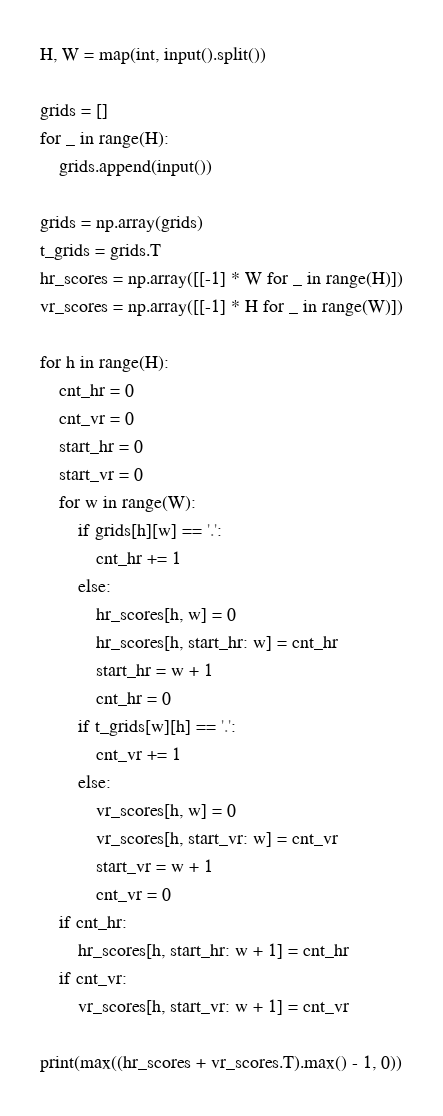<code> <loc_0><loc_0><loc_500><loc_500><_Python_>H, W = map(int, input().split())

grids = []
for _ in range(H):
    grids.append(input())

grids = np.array(grids)
t_grids = grids.T
hr_scores = np.array([[-1] * W for _ in range(H)])
vr_scores = np.array([[-1] * H for _ in range(W)])

for h in range(H):
    cnt_hr = 0
    cnt_vr = 0
    start_hr = 0
    start_vr = 0
    for w in range(W):
        if grids[h][w] == '.':
            cnt_hr += 1
        else:
            hr_scores[h, w] = 0
            hr_scores[h, start_hr: w] = cnt_hr
            start_hr = w + 1
            cnt_hr = 0
        if t_grids[w][h] == '.':
            cnt_vr += 1
        else:
            vr_scores[h, w] = 0
            vr_scores[h, start_vr: w] = cnt_vr
            start_vr = w + 1
            cnt_vr = 0
    if cnt_hr:
        hr_scores[h, start_hr: w + 1] = cnt_hr
    if cnt_vr:
        vr_scores[h, start_vr: w + 1] = cnt_vr
        
print(max((hr_scores + vr_scores.T).max() - 1, 0))</code> 